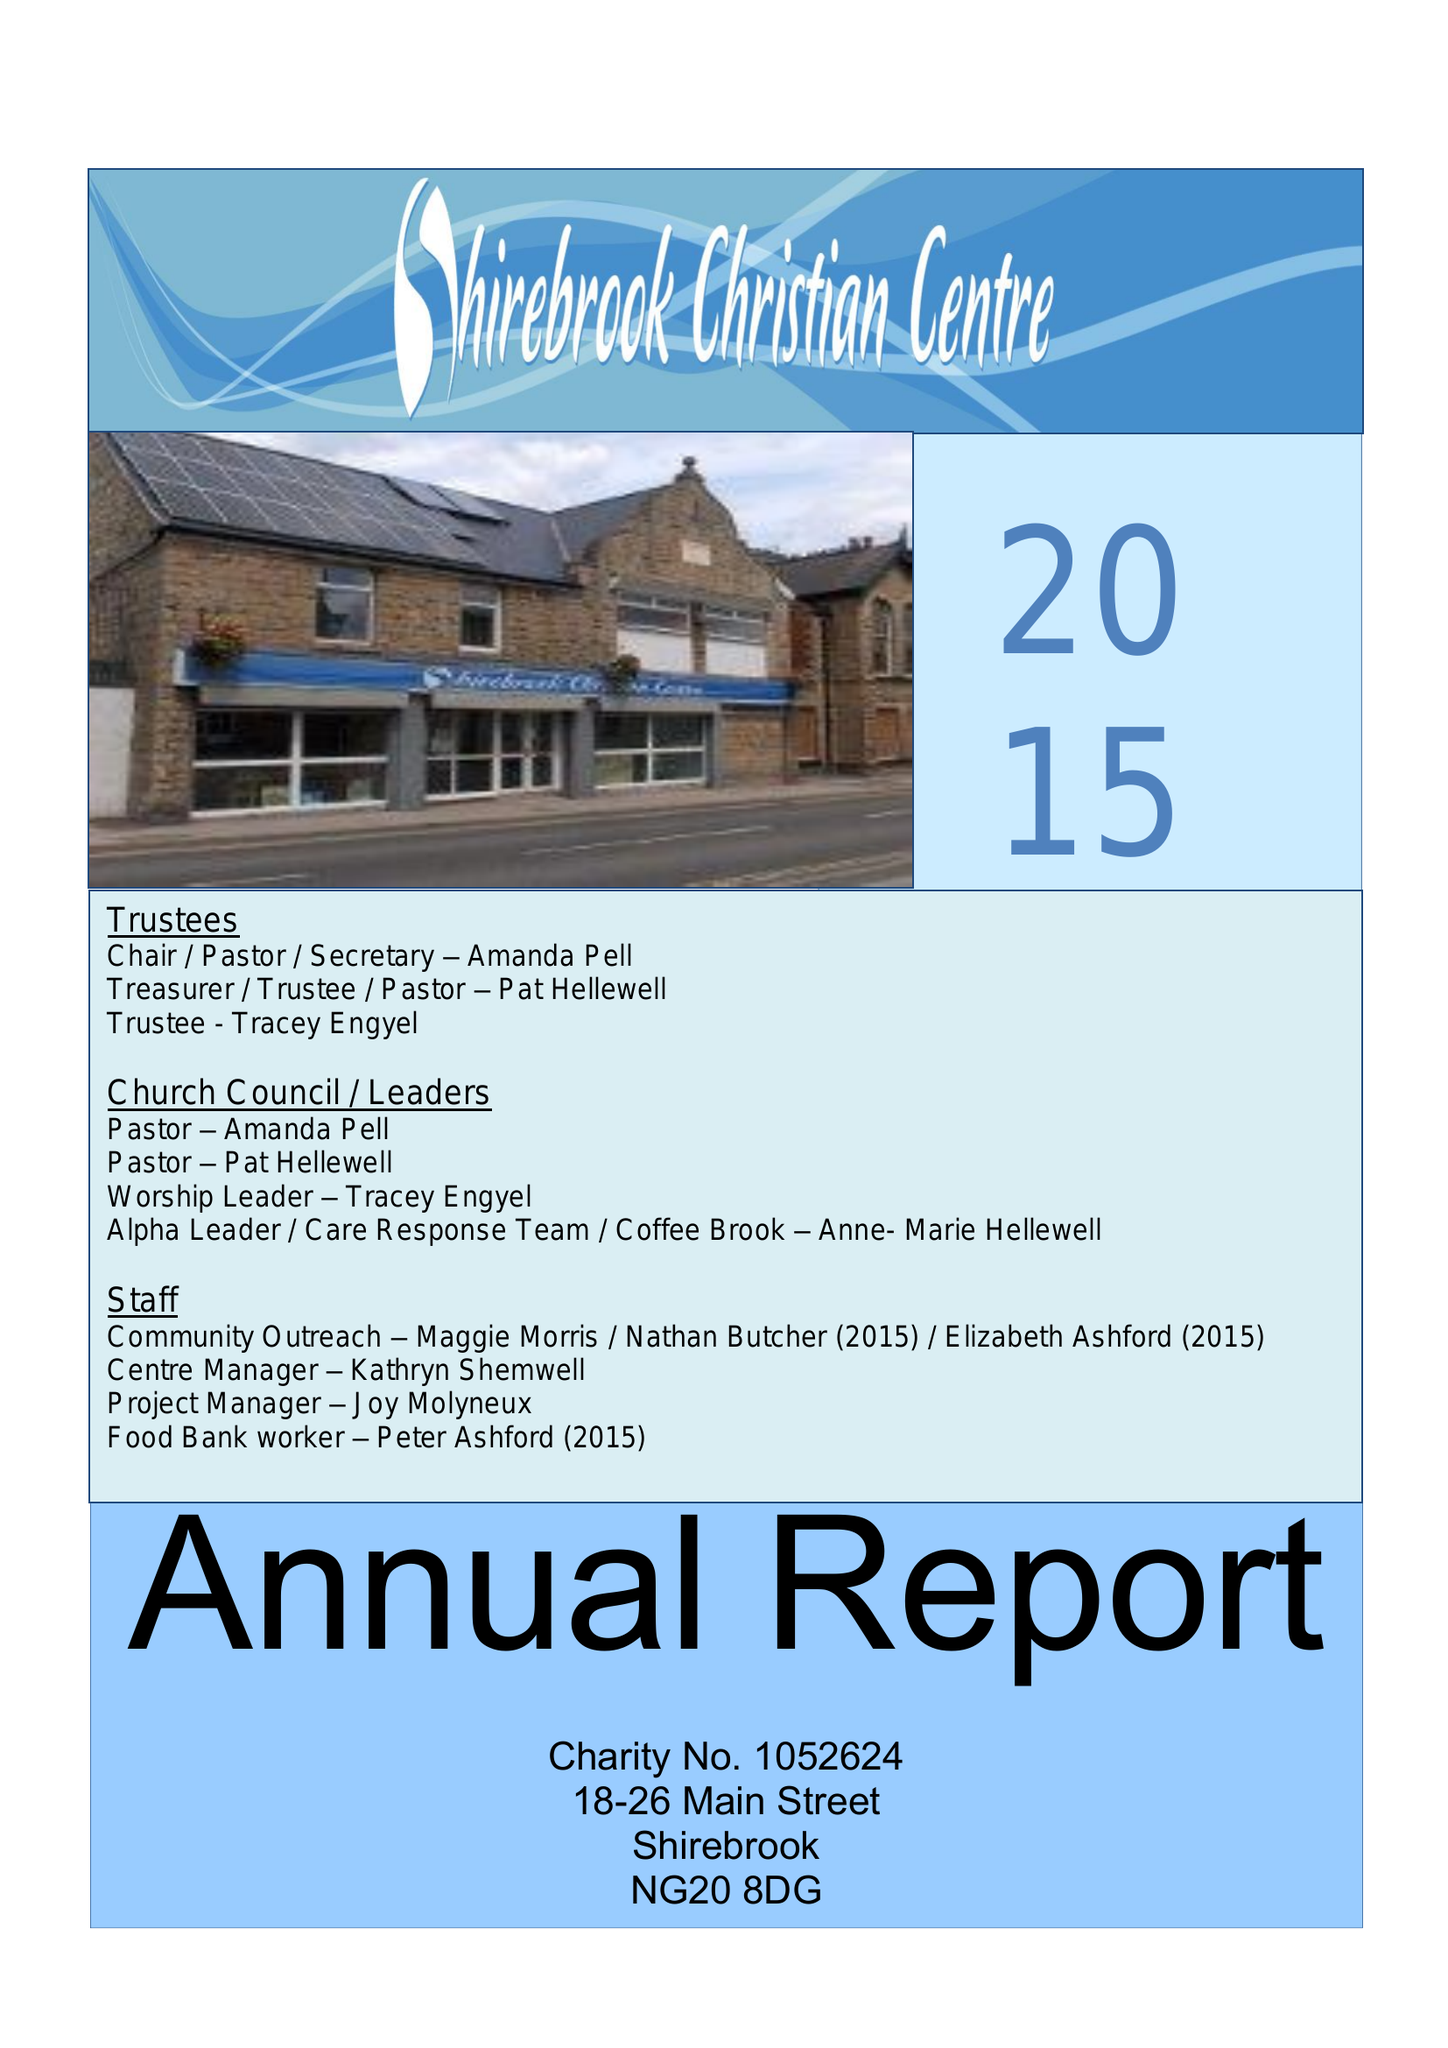What is the value for the charity_number?
Answer the question using a single word or phrase. 1052624 